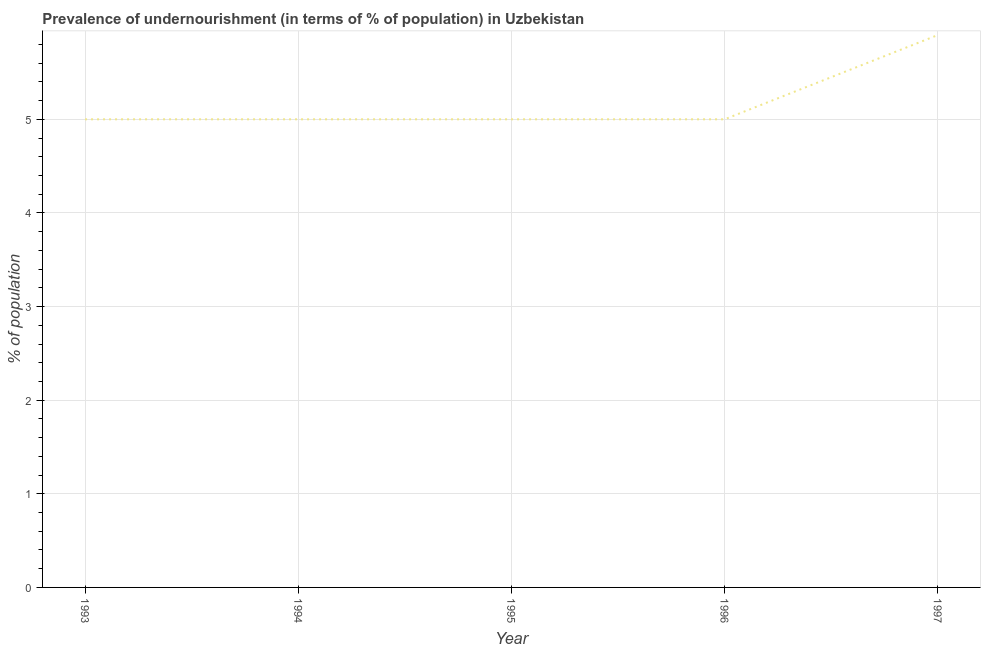Across all years, what is the maximum percentage of undernourished population?
Provide a short and direct response. 5.9. What is the sum of the percentage of undernourished population?
Ensure brevity in your answer.  25.9. What is the difference between the percentage of undernourished population in 1993 and 1996?
Keep it short and to the point. 0. What is the average percentage of undernourished population per year?
Offer a very short reply. 5.18. What is the median percentage of undernourished population?
Make the answer very short. 5. In how many years, is the percentage of undernourished population greater than 2.6 %?
Offer a very short reply. 5. Do a majority of the years between 1994 and 1993 (inclusive) have percentage of undernourished population greater than 4 %?
Keep it short and to the point. No. Is the percentage of undernourished population in 1994 less than that in 1997?
Your response must be concise. Yes. Is the difference between the percentage of undernourished population in 1993 and 1997 greater than the difference between any two years?
Ensure brevity in your answer.  Yes. What is the difference between the highest and the second highest percentage of undernourished population?
Your answer should be very brief. 0.9. Is the sum of the percentage of undernourished population in 1994 and 1997 greater than the maximum percentage of undernourished population across all years?
Keep it short and to the point. Yes. What is the difference between the highest and the lowest percentage of undernourished population?
Make the answer very short. 0.9. Are the values on the major ticks of Y-axis written in scientific E-notation?
Offer a terse response. No. What is the title of the graph?
Give a very brief answer. Prevalence of undernourishment (in terms of % of population) in Uzbekistan. What is the label or title of the Y-axis?
Offer a terse response. % of population. What is the % of population of 1996?
Your answer should be very brief. 5. What is the difference between the % of population in 1993 and 1994?
Give a very brief answer. 0. What is the difference between the % of population in 1993 and 1995?
Your answer should be very brief. 0. What is the difference between the % of population in 1993 and 1997?
Offer a very short reply. -0.9. What is the difference between the % of population in 1994 and 1995?
Your response must be concise. 0. What is the difference between the % of population in 1994 and 1996?
Ensure brevity in your answer.  0. What is the difference between the % of population in 1994 and 1997?
Your answer should be very brief. -0.9. What is the difference between the % of population in 1995 and 1996?
Provide a short and direct response. 0. What is the difference between the % of population in 1996 and 1997?
Provide a succinct answer. -0.9. What is the ratio of the % of population in 1993 to that in 1996?
Your answer should be compact. 1. What is the ratio of the % of population in 1993 to that in 1997?
Your response must be concise. 0.85. What is the ratio of the % of population in 1994 to that in 1995?
Your response must be concise. 1. What is the ratio of the % of population in 1994 to that in 1996?
Provide a succinct answer. 1. What is the ratio of the % of population in 1994 to that in 1997?
Your response must be concise. 0.85. What is the ratio of the % of population in 1995 to that in 1997?
Make the answer very short. 0.85. What is the ratio of the % of population in 1996 to that in 1997?
Give a very brief answer. 0.85. 